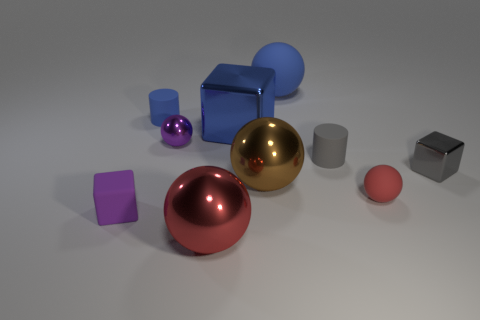Subtract all blue spheres. How many spheres are left? 4 Subtract all brown balls. How many balls are left? 4 Subtract all cyan balls. Subtract all red cylinders. How many balls are left? 5 Subtract all cylinders. How many objects are left? 8 Subtract 0 yellow balls. How many objects are left? 10 Subtract all small gray matte balls. Subtract all small gray objects. How many objects are left? 8 Add 7 red shiny things. How many red shiny things are left? 8 Add 6 tiny matte objects. How many tiny matte objects exist? 10 